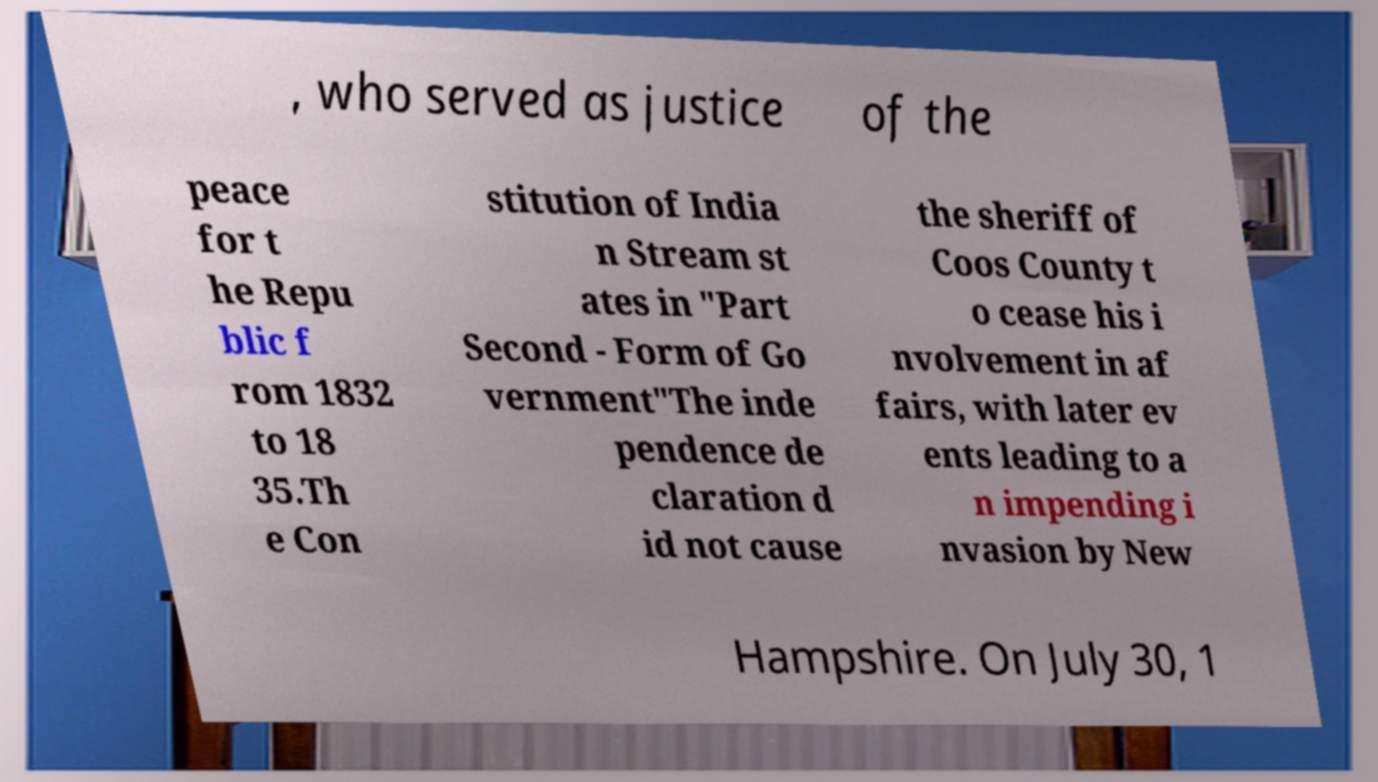Please read and relay the text visible in this image. What does it say? , who served as justice of the peace for t he Repu blic f rom 1832 to 18 35.Th e Con stitution of India n Stream st ates in "Part Second - Form of Go vernment"The inde pendence de claration d id not cause the sheriff of Coos County t o cease his i nvolvement in af fairs, with later ev ents leading to a n impending i nvasion by New Hampshire. On July 30, 1 